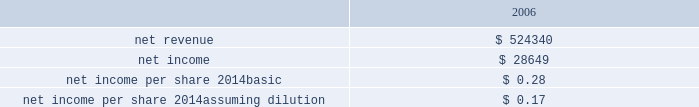Hologic , inc .
Notes to consolidated financial statements ( continued ) ( in thousands , except per share data ) as part of the purchase price allocation , all intangible assets that were a part of the acquisition were identified and valued .
It was determined that only customer relationship , trade name , developed technology and know how and in-process research and development had separately identifiable values .
Customer relationship represents suros large installed base that are expected to purchase disposable products on a regular basis .
Trade name represents the suros product names that the company intends to continue to use .
Developed technology and know how represents currently marketable purchased products that the company continues to resell as well as utilize to enhance and incorporate into the company 2019s existing products .
The estimated $ 4900 of purchase price allocated to in-process research and development projects primarily related to suros 2019 disposable products .
The projects were at various stages of completion and include next generation handpiece and site marker technologies .
The company has continued to work on these projects and they are substantially complete as of september 27 , 2008 .
The deferred income tax liability relates to the tax effect of acquired identifiable intangible assets , and fair value adjustments to acquired inventory as such amounts are not deductible for tax purposes , partially offset by acquired net operating loss carry forwards that the company believes are realizable .
For all of the acquisitions discussed above , goodwill represents the excess of the purchase price over the net identifiable tangible and intangible assets acquired .
The company determined that the acquisition of each aeg , biolucent , r2 and suros resulted in the recognition of goodwill primarily because of synergies unique to the company and the strength of its acquired workforce .
Supplemental unaudited pro-forma information the following unaudited pro forma information presents the consolidated results of operations of the company , r2 and suros as if the acquisitions had occurred at the beginning of fiscal 2006 , with pro forma adjustments to give effect to amortization of intangible assets , an increase in interest expense on acquisition financing and certain other adjustments together with related tax effects: .
The $ 15100 charge for purchased research and development that was a direct result of these two transactions is excluded from the unaudited pro forma information above .
The unaudited pro forma results are not necessarily indicative of the results that the company would have attained had the acquisitions of both r2 and suros occurred at the beginning of the periods presented .
Acquisition of intangible assets on september 29 , 2005 , pursuant to an asset purchase agreement between the company and fischer imaging corporation ( 201cfischer 201d ) , dated june 22 , 2005 , the company acquired the intellectual property and customer lists relating to fischer 2019s mammography business and products for $ 26900 in cash and cancellation of the principal and interest outstanding under a $ 5000 secured loan previously provided by the company to fischer .
The aggregate purchase price for the fischer intellectual property and customer lists was approximately $ 33000 , which included approximately $ 1000 related to direct acquisition costs .
In accordance with emerging issues task force issue no .
98-3 , determining whether a non-monetary transaction involved receipt of .
What would pro forma net income have been if the charge for purchased research and development had been expensed? 
Computations: (28649 - 15100)
Answer: 13549.0. 